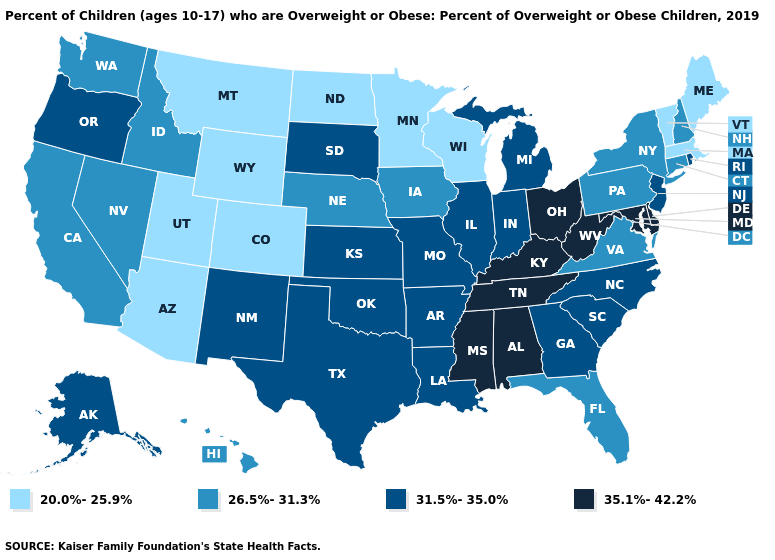Does Arkansas have the highest value in the USA?
Give a very brief answer. No. Is the legend a continuous bar?
Give a very brief answer. No. Among the states that border Oklahoma , does Colorado have the lowest value?
Concise answer only. Yes. Name the states that have a value in the range 20.0%-25.9%?
Concise answer only. Arizona, Colorado, Maine, Massachusetts, Minnesota, Montana, North Dakota, Utah, Vermont, Wisconsin, Wyoming. Name the states that have a value in the range 35.1%-42.2%?
Be succinct. Alabama, Delaware, Kentucky, Maryland, Mississippi, Ohio, Tennessee, West Virginia. Which states have the lowest value in the USA?
Keep it brief. Arizona, Colorado, Maine, Massachusetts, Minnesota, Montana, North Dakota, Utah, Vermont, Wisconsin, Wyoming. What is the value of Arkansas?
Give a very brief answer. 31.5%-35.0%. What is the highest value in the USA?
Keep it brief. 35.1%-42.2%. What is the lowest value in states that border West Virginia?
Answer briefly. 26.5%-31.3%. Among the states that border Mississippi , does Arkansas have the lowest value?
Give a very brief answer. Yes. Does the map have missing data?
Concise answer only. No. Among the states that border Massachusetts , does Vermont have the lowest value?
Give a very brief answer. Yes. Name the states that have a value in the range 20.0%-25.9%?
Concise answer only. Arizona, Colorado, Maine, Massachusetts, Minnesota, Montana, North Dakota, Utah, Vermont, Wisconsin, Wyoming. What is the highest value in states that border Rhode Island?
Concise answer only. 26.5%-31.3%. What is the highest value in the USA?
Answer briefly. 35.1%-42.2%. 